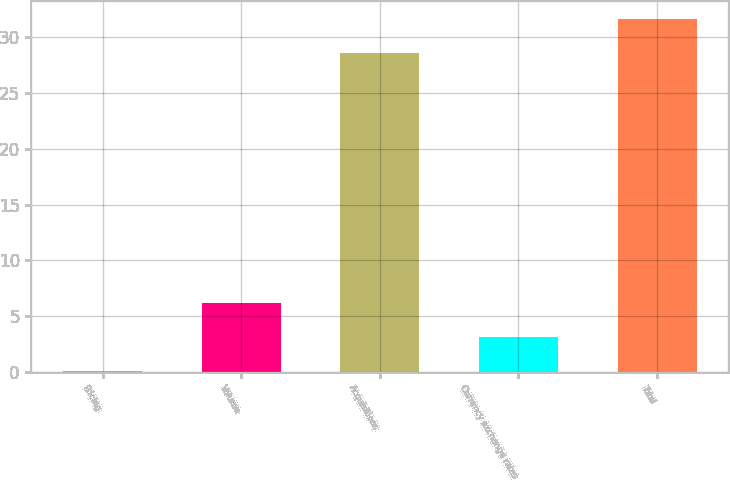Convert chart to OTSL. <chart><loc_0><loc_0><loc_500><loc_500><bar_chart><fcel>Pricing<fcel>Volume<fcel>Acquisitions<fcel>Currency exchange rates<fcel>Total<nl><fcel>0.1<fcel>6.22<fcel>28.6<fcel>3.16<fcel>31.66<nl></chart> 